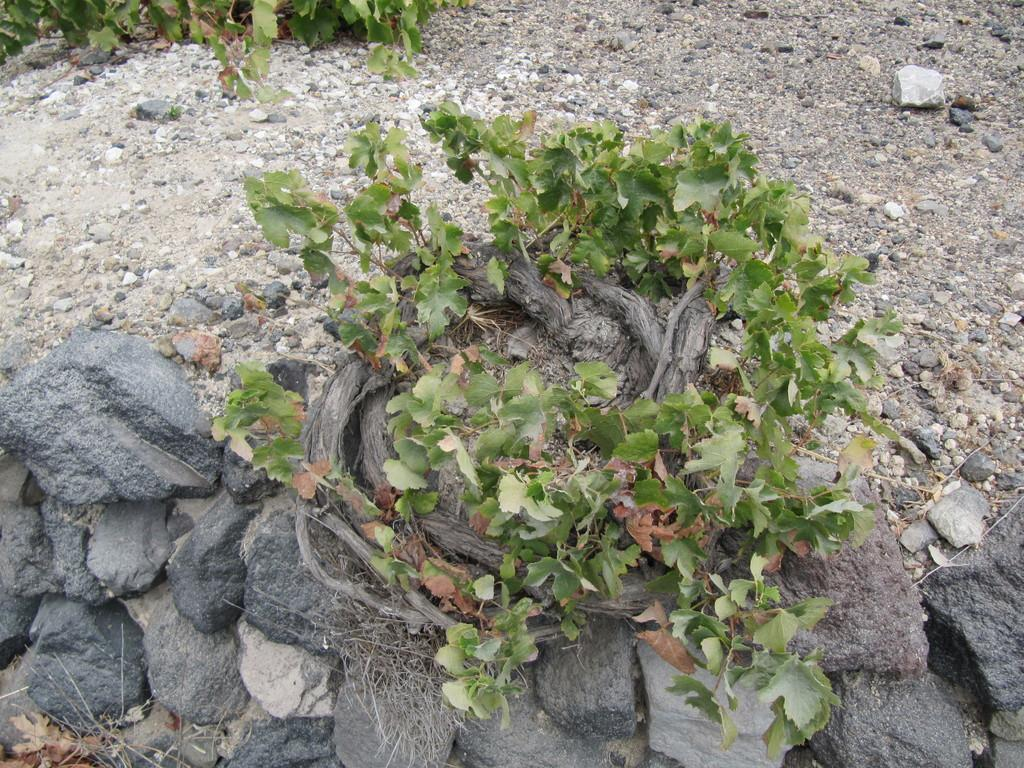What is the primary feature of the image? The primary feature of the image is the presence of many stones. What else can be seen on the ground in the image? There are plants on the ground in the image. What is located at the bottom of the image? There are rocks at the bottom of the image. What type of finger can be seen holding a jail key in the image? There is no finger or jail key present in the image; it primarily features stones, plants, and rocks. 